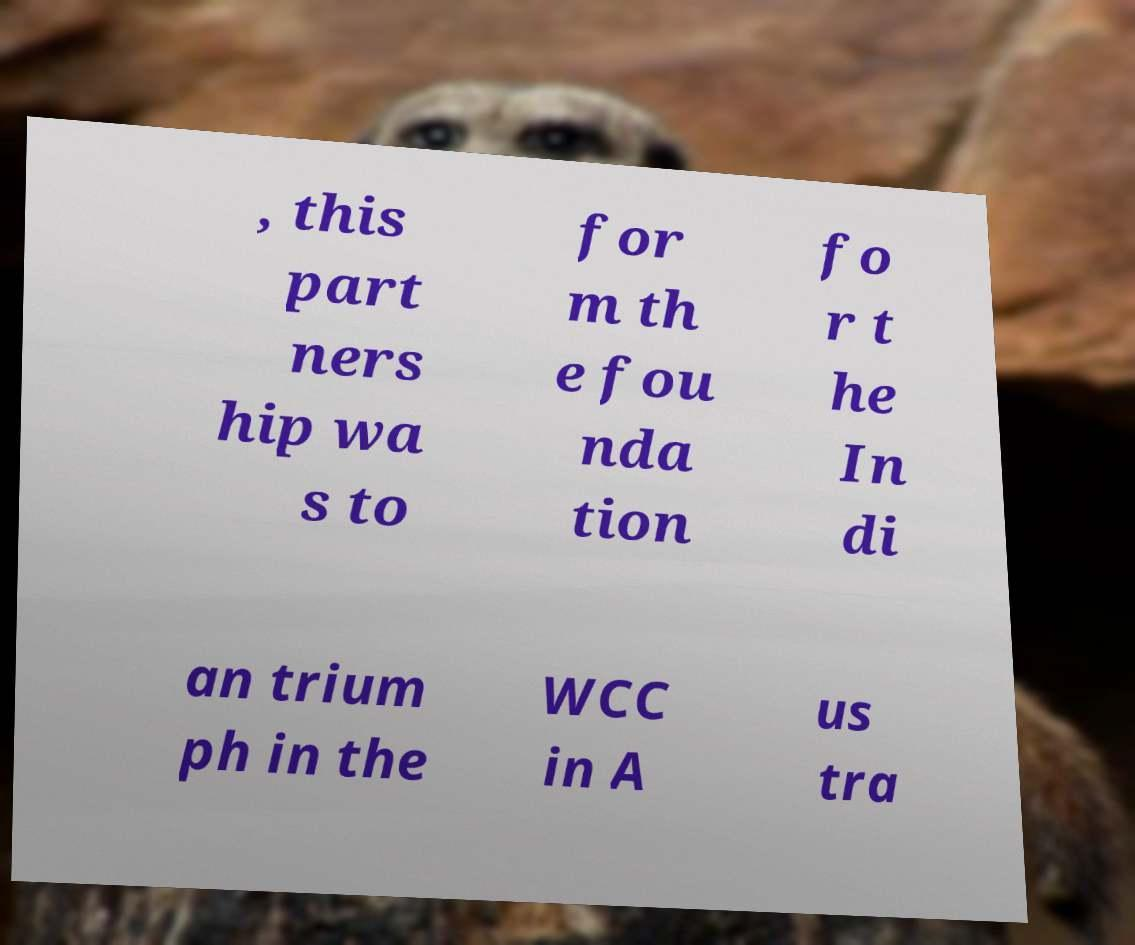Could you assist in decoding the text presented in this image and type it out clearly? , this part ners hip wa s to for m th e fou nda tion fo r t he In di an trium ph in the WCC in A us tra 